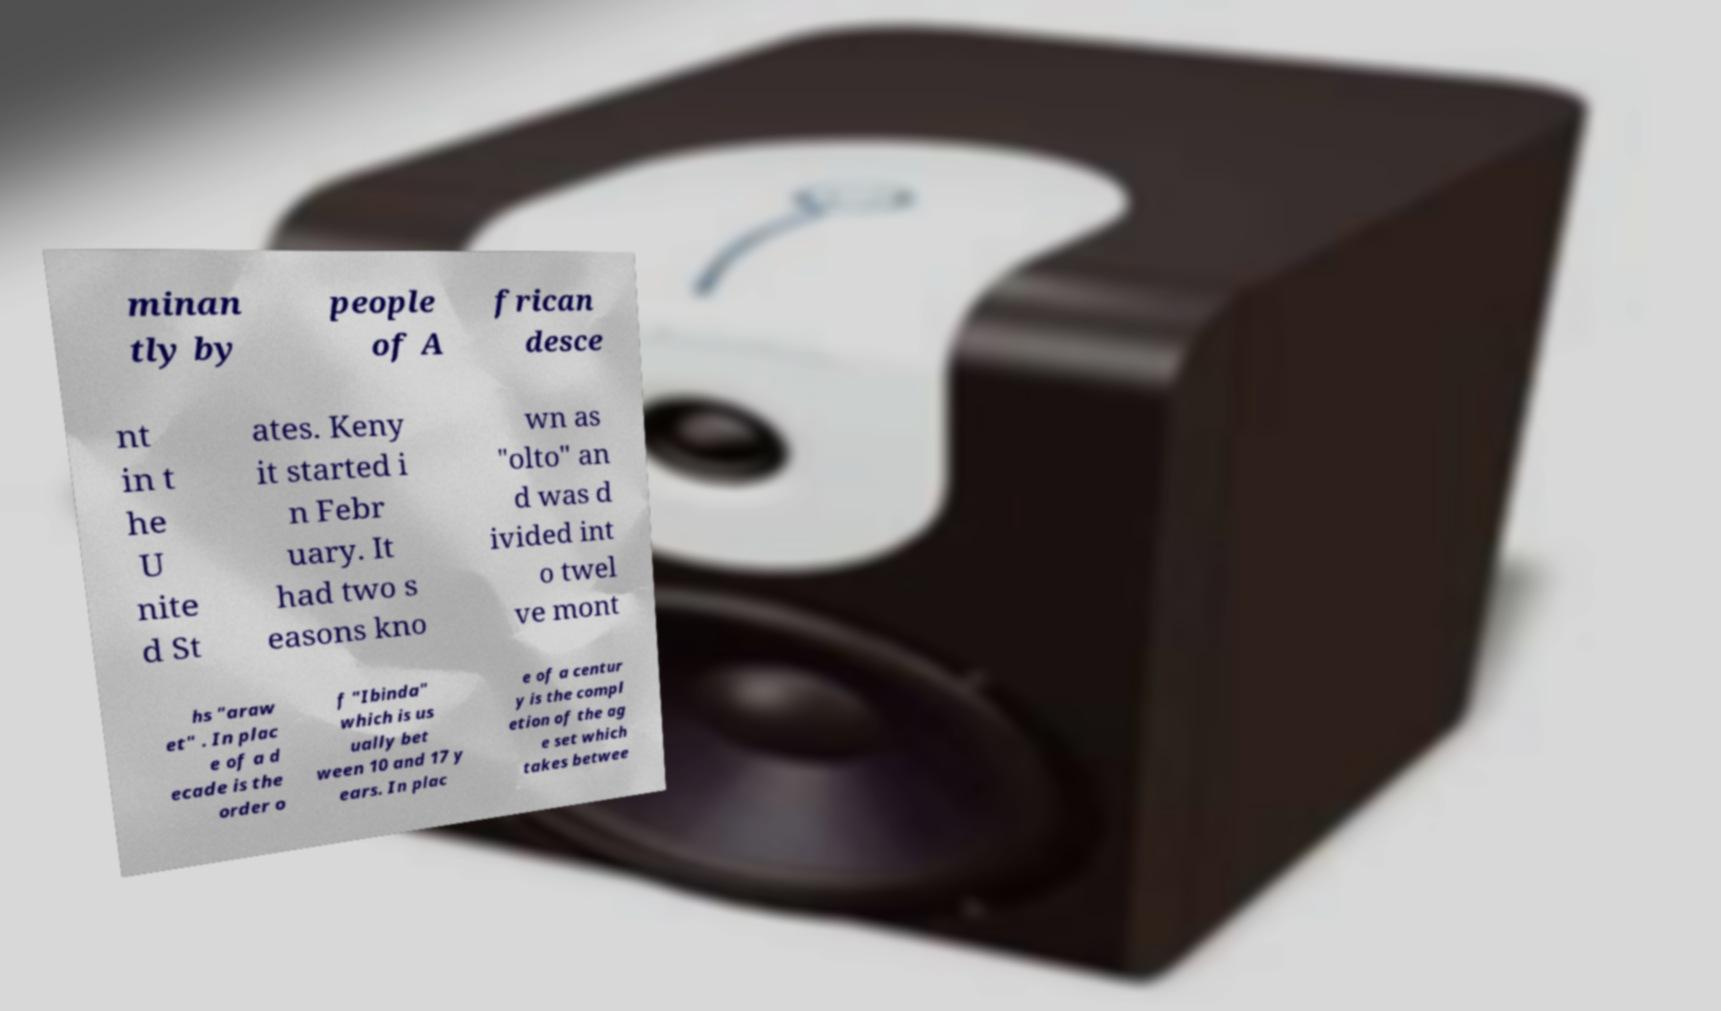Can you read and provide the text displayed in the image?This photo seems to have some interesting text. Can you extract and type it out for me? minan tly by people of A frican desce nt in t he U nite d St ates. Keny it started i n Febr uary. It had two s easons kno wn as "olto" an d was d ivided int o twel ve mont hs "araw et" . In plac e of a d ecade is the order o f "Ibinda" which is us ually bet ween 10 and 17 y ears. In plac e of a centur y is the compl etion of the ag e set which takes betwee 